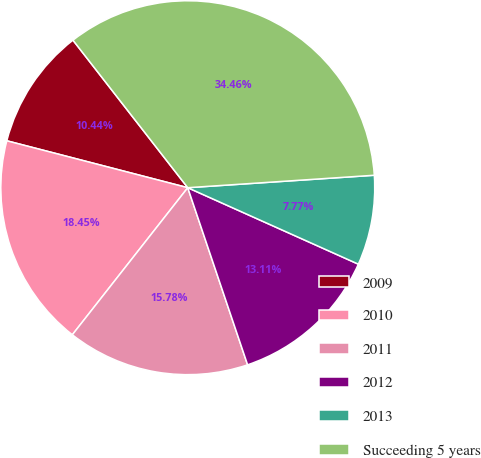Convert chart. <chart><loc_0><loc_0><loc_500><loc_500><pie_chart><fcel>2009<fcel>2010<fcel>2011<fcel>2012<fcel>2013<fcel>Succeeding 5 years<nl><fcel>10.44%<fcel>18.45%<fcel>15.78%<fcel>13.11%<fcel>7.77%<fcel>34.47%<nl></chart> 